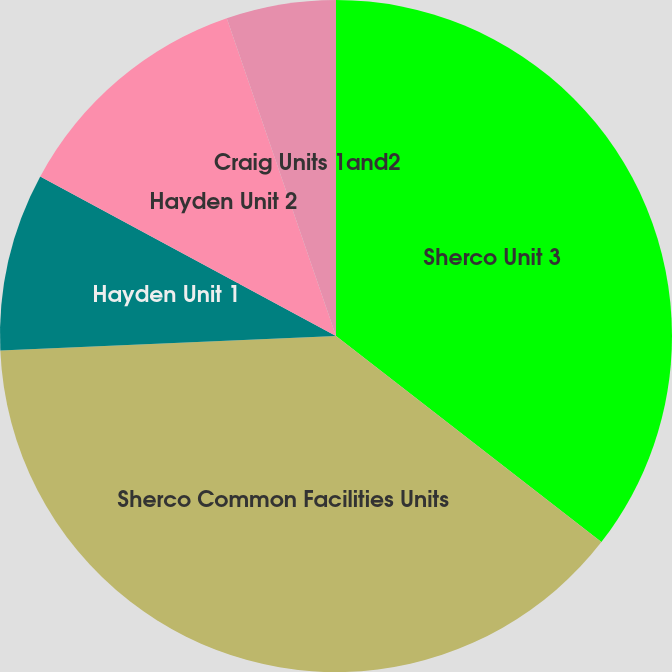<chart> <loc_0><loc_0><loc_500><loc_500><pie_chart><fcel>Sherco Unit 3<fcel>Sherco Common Facilities Units<fcel>Hayden Unit 1<fcel>Hayden Unit 2<fcel>Craig Units 1and2<nl><fcel>35.51%<fcel>38.8%<fcel>8.56%<fcel>11.86%<fcel>5.27%<nl></chart> 